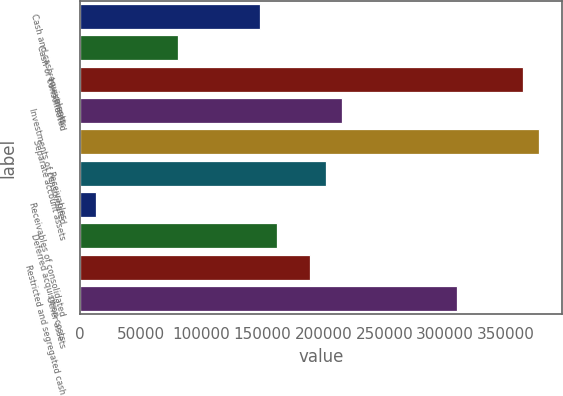<chart> <loc_0><loc_0><loc_500><loc_500><bar_chart><fcel>Cash and cash equivalents<fcel>Cash of consolidated<fcel>Investments<fcel>Investments of consolidated<fcel>Separate account assets<fcel>Receivables<fcel>Receivables of consolidated<fcel>Deferred acquisition costs<fcel>Restricted and segregated cash<fcel>Other assets<nl><fcel>148202<fcel>80838.6<fcel>363763<fcel>215565<fcel>377236<fcel>202092<fcel>13475.6<fcel>161674<fcel>188619<fcel>309873<nl></chart> 